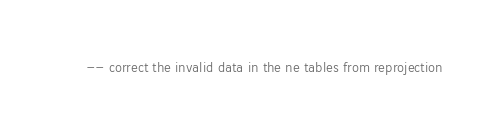Convert code to text. <code><loc_0><loc_0><loc_500><loc_500><_SQL_>-- correct the invalid data in the ne tables from reprojection</code> 